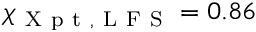Convert formula to latex. <formula><loc_0><loc_0><loc_500><loc_500>\chi _ { X p t , L F S } = 0 . 8 6</formula> 